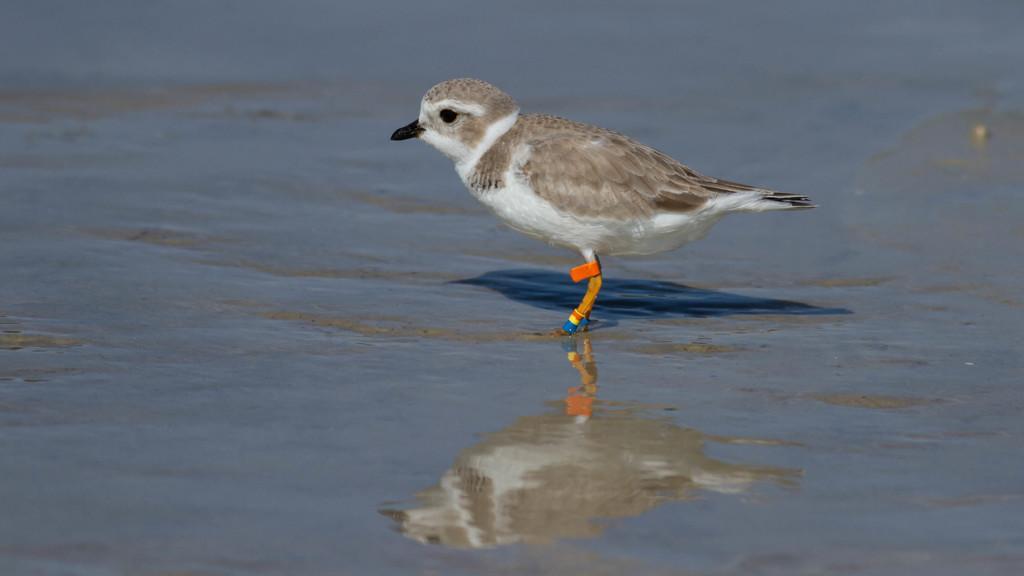In one or two sentences, can you explain what this image depicts? In this image we can see a bird standing in the water. 